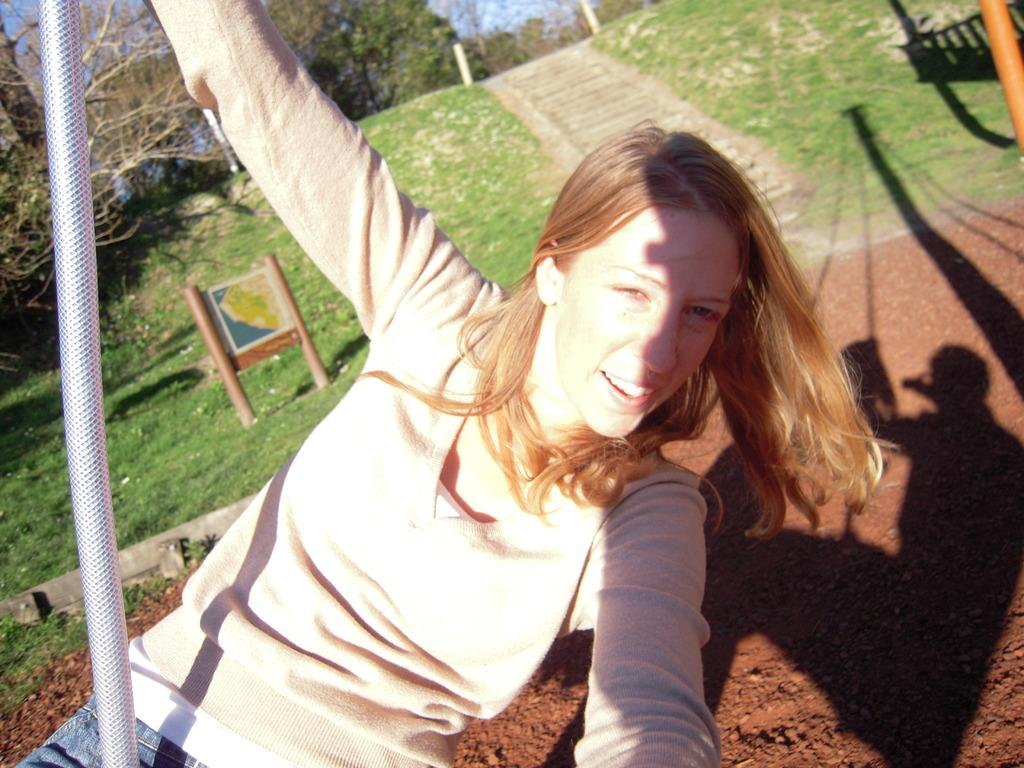What is the girl in the image holding? The girl is holding a pole in the image. What can be seen on the ground in the image? There is a reflection of a person on a swing on the ground. What type of natural vegetation is present in the image? There are trees in the image. How many poles can be seen in the image? There are poles in the image. What is displayed on the board in the image? There is an image on the board in the image. What is visible in the background of the image? The sky is visible in the image. Is there a kettle visible in the image? No, there is no kettle present in the image. What attempt is the girl making in the image? The girl is not attempting anything in the image; she is simply holding a pole. 